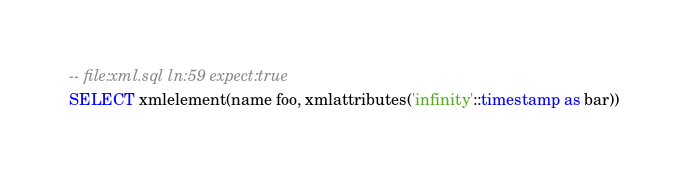<code> <loc_0><loc_0><loc_500><loc_500><_SQL_>-- file:xml.sql ln:59 expect:true
SELECT xmlelement(name foo, xmlattributes('infinity'::timestamp as bar))
</code> 